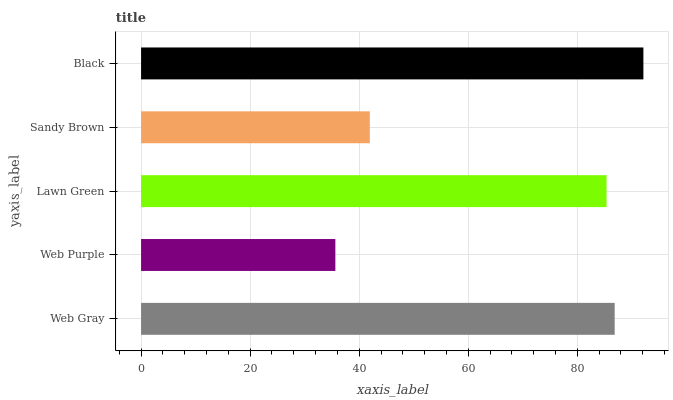Is Web Purple the minimum?
Answer yes or no. Yes. Is Black the maximum?
Answer yes or no. Yes. Is Lawn Green the minimum?
Answer yes or no. No. Is Lawn Green the maximum?
Answer yes or no. No. Is Lawn Green greater than Web Purple?
Answer yes or no. Yes. Is Web Purple less than Lawn Green?
Answer yes or no. Yes. Is Web Purple greater than Lawn Green?
Answer yes or no. No. Is Lawn Green less than Web Purple?
Answer yes or no. No. Is Lawn Green the high median?
Answer yes or no. Yes. Is Lawn Green the low median?
Answer yes or no. Yes. Is Web Gray the high median?
Answer yes or no. No. Is Web Gray the low median?
Answer yes or no. No. 